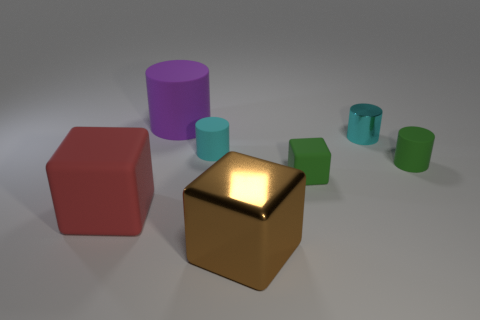Is the tiny cube made of the same material as the big purple cylinder? Based on the visual indicators in the image, it appears that the tiny cube and the big purple cylinder have different textures and reflectivity. While the tiny cube has a distinct metallic sheen, suggesting it could be made of metal or a polished material, the big purple cylinder looks more matte, indicating a possibly different, less reflective material such as plastic. 